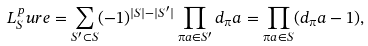Convert formula to latex. <formula><loc_0><loc_0><loc_500><loc_500>L _ { S } ^ { p } u r e = \sum _ { S ^ { \prime } \subset S } ( - 1 ) ^ { | S | - | S ^ { \prime } | } \prod _ { \i a \in S ^ { \prime } } d _ { \i } a = \prod _ { \i a \in S } ( d _ { \i } a - 1 ) ,</formula> 